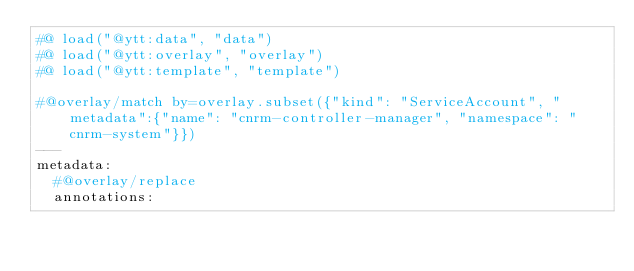Convert code to text. <code><loc_0><loc_0><loc_500><loc_500><_YAML_>#@ load("@ytt:data", "data")
#@ load("@ytt:overlay", "overlay")
#@ load("@ytt:template", "template")

#@overlay/match by=overlay.subset({"kind": "ServiceAccount", "metadata":{"name": "cnrm-controller-manager", "namespace": "cnrm-system"}})
---
metadata:
  #@overlay/replace
  annotations:</code> 